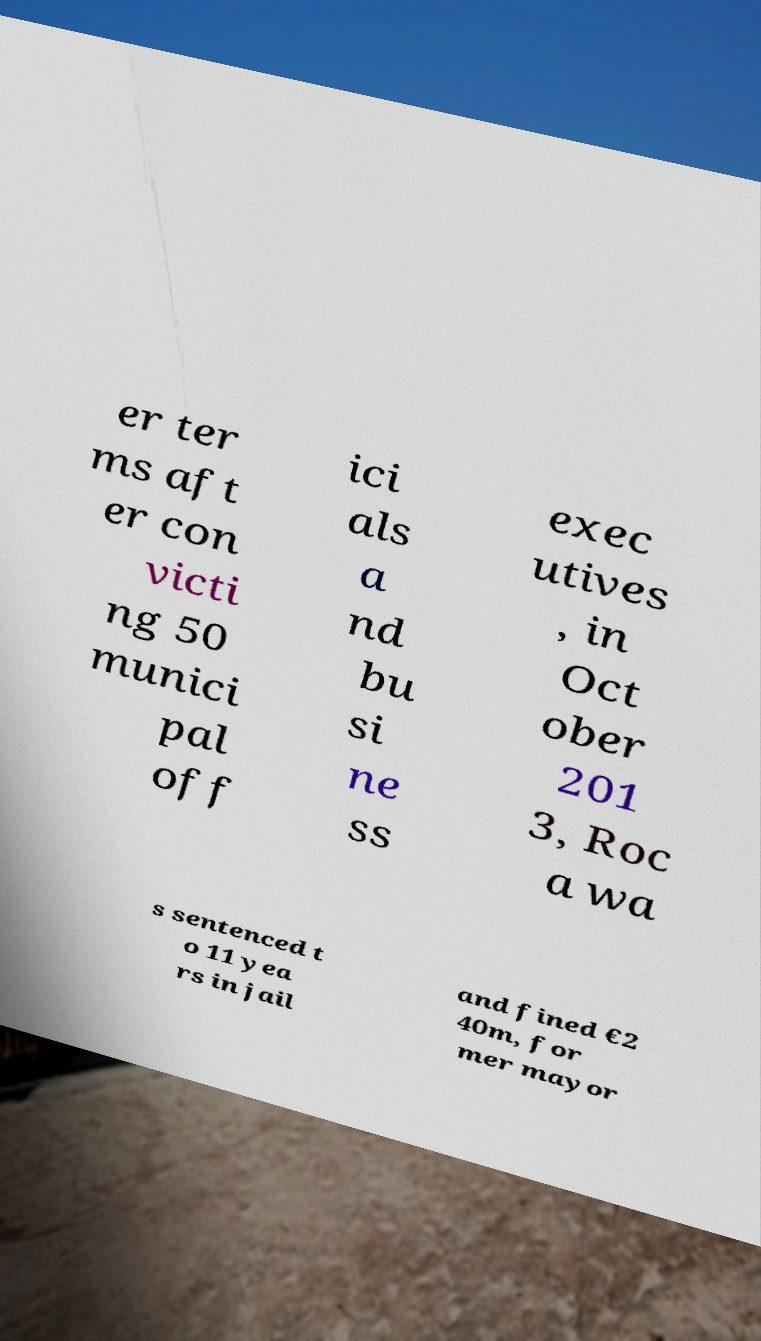Can you accurately transcribe the text from the provided image for me? er ter ms aft er con victi ng 50 munici pal off ici als a nd bu si ne ss exec utives , in Oct ober 201 3, Roc a wa s sentenced t o 11 yea rs in jail and fined €2 40m, for mer mayor 